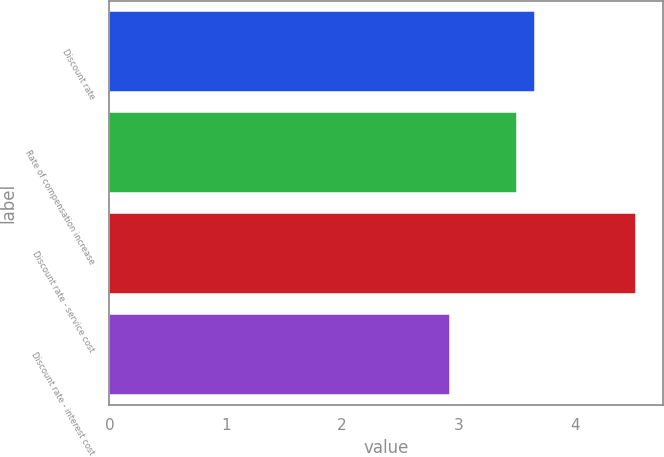Convert chart to OTSL. <chart><loc_0><loc_0><loc_500><loc_500><bar_chart><fcel>Discount rate<fcel>Rate of compensation increase<fcel>Discount rate - service cost<fcel>Discount rate - interest cost<nl><fcel>3.66<fcel>3.5<fcel>4.53<fcel>2.93<nl></chart> 